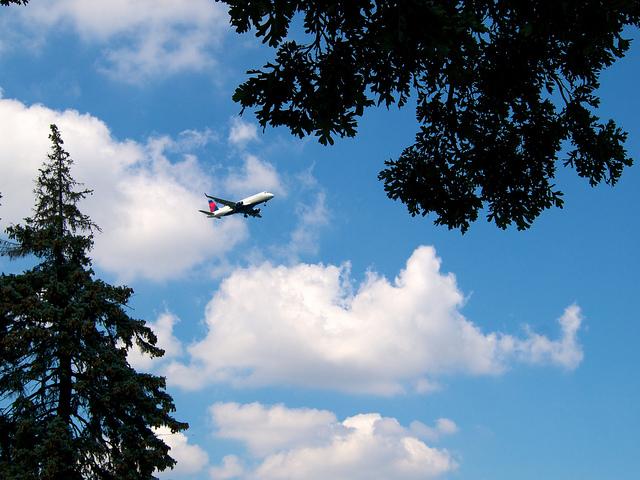Is the plane in the air?
Short answer required. Yes. Is it raining?
Give a very brief answer. No. What type of transportation is shown?
Be succinct. Airplane. How many clouds in this picture?
Give a very brief answer. 4. Are those  branches, with their bunches of leaves at their ends, reminiscent of pom-poms?
Be succinct. No. What kind of trees are there?
Be succinct. Pine. Is it bright out or dark?
Quick response, please. Bright. There are two different colored umbrellas. What are they?
Concise answer only. No. What kind of plant is on the left?
Give a very brief answer. Tree. What is on the airplane?
Quick response, please. People. What animal is shown?
Keep it brief. None. What time of the day is it?
Answer briefly. Afternoon. Is there a kite in the image?
Concise answer only. No. How many trees are in the picture?
Give a very brief answer. 2. What time of year is this?
Concise answer only. Summer. What is shining so brightly?
Keep it brief. Sun. Is there a view of the scenery?
Short answer required. No. Do any of the planes being protected?
Quick response, please. No. How many trees are visible?
Keep it brief. 2. Do the tree branches make the letter "V"?
Keep it brief. Yes. Overcast or sunny?
Short answer required. Sunny. What color is the sky?
Short answer required. Blue. Are there any bricks in the photo?
Short answer required. No. Is it windy?
Be succinct. No. What is the main color in this image?
Keep it brief. Blue. What color is the plane's body?
Concise answer only. White. Are there only stuffed bears on the tree?
Write a very short answer. No. What is the main color of this train?
Short answer required. White. What kind of trees dominate the picture?
Answer briefly. Pine. What is in the sky?
Keep it brief. Plane. What season of the year is it?
Give a very brief answer. Summer. What hobby is shown?
Give a very brief answer. Flying. Are there clouds?
Short answer required. Yes. What is clarity of photo?
Keep it brief. Clear. Is it a passenger jet?
Short answer required. Yes. What is the blue object?
Keep it brief. Sky. Is there a lot of color in the scene?
Give a very brief answer. Yes. What color is the cloud on the left?
Concise answer only. White. Is this entertaining?
Keep it brief. No. 